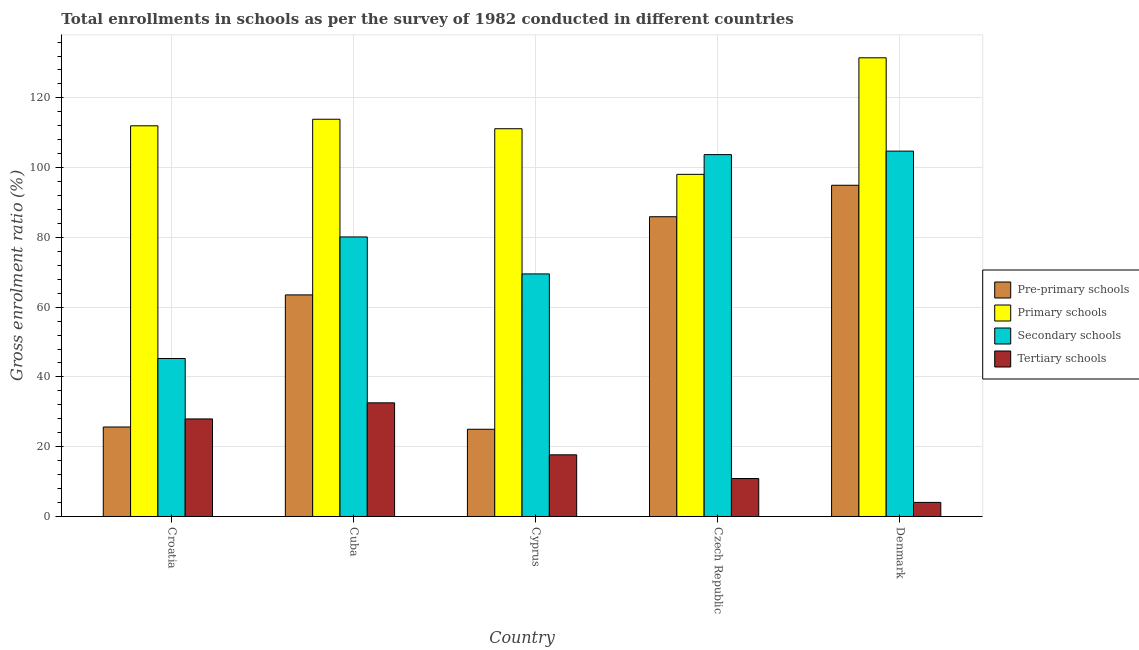How many different coloured bars are there?
Your answer should be compact. 4. How many groups of bars are there?
Provide a succinct answer. 5. Are the number of bars per tick equal to the number of legend labels?
Offer a terse response. Yes. Are the number of bars on each tick of the X-axis equal?
Your response must be concise. Yes. How many bars are there on the 5th tick from the left?
Your answer should be very brief. 4. What is the label of the 2nd group of bars from the left?
Provide a succinct answer. Cuba. In how many cases, is the number of bars for a given country not equal to the number of legend labels?
Offer a terse response. 0. What is the gross enrolment ratio in pre-primary schools in Denmark?
Your response must be concise. 94.95. Across all countries, what is the maximum gross enrolment ratio in pre-primary schools?
Offer a very short reply. 94.95. Across all countries, what is the minimum gross enrolment ratio in tertiary schools?
Offer a terse response. 4.04. In which country was the gross enrolment ratio in pre-primary schools minimum?
Your response must be concise. Cyprus. What is the total gross enrolment ratio in secondary schools in the graph?
Your answer should be compact. 403.42. What is the difference between the gross enrolment ratio in primary schools in Cuba and that in Denmark?
Offer a terse response. -17.61. What is the difference between the gross enrolment ratio in primary schools in Denmark and the gross enrolment ratio in secondary schools in Cuba?
Your answer should be compact. 51.35. What is the average gross enrolment ratio in primary schools per country?
Make the answer very short. 113.32. What is the difference between the gross enrolment ratio in secondary schools and gross enrolment ratio in tertiary schools in Cyprus?
Offer a very short reply. 51.86. In how many countries, is the gross enrolment ratio in secondary schools greater than 124 %?
Your response must be concise. 0. What is the ratio of the gross enrolment ratio in secondary schools in Croatia to that in Czech Republic?
Provide a short and direct response. 0.44. What is the difference between the highest and the second highest gross enrolment ratio in secondary schools?
Your answer should be very brief. 1. What is the difference between the highest and the lowest gross enrolment ratio in secondary schools?
Offer a very short reply. 59.45. Is the sum of the gross enrolment ratio in primary schools in Cuba and Cyprus greater than the maximum gross enrolment ratio in pre-primary schools across all countries?
Keep it short and to the point. Yes. What does the 4th bar from the left in Cuba represents?
Give a very brief answer. Tertiary schools. What does the 4th bar from the right in Cuba represents?
Offer a very short reply. Pre-primary schools. How many bars are there?
Offer a very short reply. 20. Are all the bars in the graph horizontal?
Ensure brevity in your answer.  No. What is the difference between two consecutive major ticks on the Y-axis?
Keep it short and to the point. 20. Are the values on the major ticks of Y-axis written in scientific E-notation?
Ensure brevity in your answer.  No. Does the graph contain grids?
Ensure brevity in your answer.  Yes. Where does the legend appear in the graph?
Ensure brevity in your answer.  Center right. How many legend labels are there?
Offer a terse response. 4. What is the title of the graph?
Give a very brief answer. Total enrollments in schools as per the survey of 1982 conducted in different countries. What is the Gross enrolment ratio (%) of Pre-primary schools in Croatia?
Your answer should be very brief. 25.65. What is the Gross enrolment ratio (%) in Primary schools in Croatia?
Your answer should be very brief. 111.99. What is the Gross enrolment ratio (%) of Secondary schools in Croatia?
Keep it short and to the point. 45.29. What is the Gross enrolment ratio (%) of Tertiary schools in Croatia?
Ensure brevity in your answer.  27.97. What is the Gross enrolment ratio (%) of Pre-primary schools in Cuba?
Provide a short and direct response. 63.52. What is the Gross enrolment ratio (%) in Primary schools in Cuba?
Your answer should be very brief. 113.87. What is the Gross enrolment ratio (%) in Secondary schools in Cuba?
Keep it short and to the point. 80.13. What is the Gross enrolment ratio (%) of Tertiary schools in Cuba?
Offer a very short reply. 32.58. What is the Gross enrolment ratio (%) of Pre-primary schools in Cyprus?
Offer a terse response. 25.01. What is the Gross enrolment ratio (%) in Primary schools in Cyprus?
Provide a succinct answer. 111.15. What is the Gross enrolment ratio (%) of Secondary schools in Cyprus?
Your answer should be very brief. 69.53. What is the Gross enrolment ratio (%) of Tertiary schools in Cyprus?
Make the answer very short. 17.68. What is the Gross enrolment ratio (%) in Pre-primary schools in Czech Republic?
Offer a terse response. 85.93. What is the Gross enrolment ratio (%) in Primary schools in Czech Republic?
Your answer should be very brief. 98.08. What is the Gross enrolment ratio (%) of Secondary schools in Czech Republic?
Provide a succinct answer. 103.73. What is the Gross enrolment ratio (%) of Tertiary schools in Czech Republic?
Offer a very short reply. 10.88. What is the Gross enrolment ratio (%) of Pre-primary schools in Denmark?
Your answer should be very brief. 94.95. What is the Gross enrolment ratio (%) of Primary schools in Denmark?
Your answer should be compact. 131.48. What is the Gross enrolment ratio (%) in Secondary schools in Denmark?
Ensure brevity in your answer.  104.73. What is the Gross enrolment ratio (%) in Tertiary schools in Denmark?
Provide a short and direct response. 4.04. Across all countries, what is the maximum Gross enrolment ratio (%) in Pre-primary schools?
Keep it short and to the point. 94.95. Across all countries, what is the maximum Gross enrolment ratio (%) in Primary schools?
Provide a succinct answer. 131.48. Across all countries, what is the maximum Gross enrolment ratio (%) of Secondary schools?
Make the answer very short. 104.73. Across all countries, what is the maximum Gross enrolment ratio (%) in Tertiary schools?
Give a very brief answer. 32.58. Across all countries, what is the minimum Gross enrolment ratio (%) in Pre-primary schools?
Your response must be concise. 25.01. Across all countries, what is the minimum Gross enrolment ratio (%) in Primary schools?
Keep it short and to the point. 98.08. Across all countries, what is the minimum Gross enrolment ratio (%) in Secondary schools?
Make the answer very short. 45.29. Across all countries, what is the minimum Gross enrolment ratio (%) in Tertiary schools?
Provide a succinct answer. 4.04. What is the total Gross enrolment ratio (%) of Pre-primary schools in the graph?
Your answer should be compact. 295.05. What is the total Gross enrolment ratio (%) in Primary schools in the graph?
Your answer should be compact. 566.58. What is the total Gross enrolment ratio (%) of Secondary schools in the graph?
Make the answer very short. 403.42. What is the total Gross enrolment ratio (%) in Tertiary schools in the graph?
Ensure brevity in your answer.  93.14. What is the difference between the Gross enrolment ratio (%) of Pre-primary schools in Croatia and that in Cuba?
Your answer should be very brief. -37.87. What is the difference between the Gross enrolment ratio (%) in Primary schools in Croatia and that in Cuba?
Ensure brevity in your answer.  -1.88. What is the difference between the Gross enrolment ratio (%) in Secondary schools in Croatia and that in Cuba?
Keep it short and to the point. -34.85. What is the difference between the Gross enrolment ratio (%) of Tertiary schools in Croatia and that in Cuba?
Provide a succinct answer. -4.61. What is the difference between the Gross enrolment ratio (%) in Pre-primary schools in Croatia and that in Cyprus?
Your answer should be very brief. 0.65. What is the difference between the Gross enrolment ratio (%) in Primary schools in Croatia and that in Cyprus?
Your answer should be compact. 0.84. What is the difference between the Gross enrolment ratio (%) of Secondary schools in Croatia and that in Cyprus?
Offer a terse response. -24.25. What is the difference between the Gross enrolment ratio (%) in Tertiary schools in Croatia and that in Cyprus?
Make the answer very short. 10.29. What is the difference between the Gross enrolment ratio (%) in Pre-primary schools in Croatia and that in Czech Republic?
Ensure brevity in your answer.  -60.27. What is the difference between the Gross enrolment ratio (%) in Primary schools in Croatia and that in Czech Republic?
Make the answer very short. 13.92. What is the difference between the Gross enrolment ratio (%) of Secondary schools in Croatia and that in Czech Republic?
Your answer should be very brief. -58.45. What is the difference between the Gross enrolment ratio (%) in Tertiary schools in Croatia and that in Czech Republic?
Keep it short and to the point. 17.08. What is the difference between the Gross enrolment ratio (%) in Pre-primary schools in Croatia and that in Denmark?
Ensure brevity in your answer.  -69.3. What is the difference between the Gross enrolment ratio (%) of Primary schools in Croatia and that in Denmark?
Your answer should be compact. -19.49. What is the difference between the Gross enrolment ratio (%) in Secondary schools in Croatia and that in Denmark?
Provide a short and direct response. -59.45. What is the difference between the Gross enrolment ratio (%) of Tertiary schools in Croatia and that in Denmark?
Ensure brevity in your answer.  23.93. What is the difference between the Gross enrolment ratio (%) of Pre-primary schools in Cuba and that in Cyprus?
Make the answer very short. 38.51. What is the difference between the Gross enrolment ratio (%) in Primary schools in Cuba and that in Cyprus?
Give a very brief answer. 2.72. What is the difference between the Gross enrolment ratio (%) of Secondary schools in Cuba and that in Cyprus?
Offer a terse response. 10.6. What is the difference between the Gross enrolment ratio (%) of Tertiary schools in Cuba and that in Cyprus?
Your response must be concise. 14.9. What is the difference between the Gross enrolment ratio (%) of Pre-primary schools in Cuba and that in Czech Republic?
Provide a short and direct response. -22.41. What is the difference between the Gross enrolment ratio (%) in Primary schools in Cuba and that in Czech Republic?
Make the answer very short. 15.8. What is the difference between the Gross enrolment ratio (%) of Secondary schools in Cuba and that in Czech Republic?
Provide a succinct answer. -23.6. What is the difference between the Gross enrolment ratio (%) of Tertiary schools in Cuba and that in Czech Republic?
Provide a succinct answer. 21.7. What is the difference between the Gross enrolment ratio (%) in Pre-primary schools in Cuba and that in Denmark?
Your answer should be very brief. -31.43. What is the difference between the Gross enrolment ratio (%) of Primary schools in Cuba and that in Denmark?
Provide a succinct answer. -17.61. What is the difference between the Gross enrolment ratio (%) of Secondary schools in Cuba and that in Denmark?
Your answer should be very brief. -24.6. What is the difference between the Gross enrolment ratio (%) of Tertiary schools in Cuba and that in Denmark?
Your response must be concise. 28.54. What is the difference between the Gross enrolment ratio (%) of Pre-primary schools in Cyprus and that in Czech Republic?
Your response must be concise. -60.92. What is the difference between the Gross enrolment ratio (%) of Primary schools in Cyprus and that in Czech Republic?
Offer a terse response. 13.08. What is the difference between the Gross enrolment ratio (%) in Secondary schools in Cyprus and that in Czech Republic?
Make the answer very short. -34.2. What is the difference between the Gross enrolment ratio (%) of Tertiary schools in Cyprus and that in Czech Republic?
Ensure brevity in your answer.  6.8. What is the difference between the Gross enrolment ratio (%) in Pre-primary schools in Cyprus and that in Denmark?
Your response must be concise. -69.94. What is the difference between the Gross enrolment ratio (%) of Primary schools in Cyprus and that in Denmark?
Your answer should be very brief. -20.33. What is the difference between the Gross enrolment ratio (%) of Secondary schools in Cyprus and that in Denmark?
Give a very brief answer. -35.2. What is the difference between the Gross enrolment ratio (%) of Tertiary schools in Cyprus and that in Denmark?
Offer a terse response. 13.64. What is the difference between the Gross enrolment ratio (%) in Pre-primary schools in Czech Republic and that in Denmark?
Provide a short and direct response. -9.02. What is the difference between the Gross enrolment ratio (%) of Primary schools in Czech Republic and that in Denmark?
Your answer should be very brief. -33.41. What is the difference between the Gross enrolment ratio (%) of Secondary schools in Czech Republic and that in Denmark?
Your answer should be very brief. -1. What is the difference between the Gross enrolment ratio (%) of Tertiary schools in Czech Republic and that in Denmark?
Ensure brevity in your answer.  6.84. What is the difference between the Gross enrolment ratio (%) in Pre-primary schools in Croatia and the Gross enrolment ratio (%) in Primary schools in Cuba?
Provide a short and direct response. -88.22. What is the difference between the Gross enrolment ratio (%) in Pre-primary schools in Croatia and the Gross enrolment ratio (%) in Secondary schools in Cuba?
Give a very brief answer. -54.48. What is the difference between the Gross enrolment ratio (%) of Pre-primary schools in Croatia and the Gross enrolment ratio (%) of Tertiary schools in Cuba?
Provide a short and direct response. -6.93. What is the difference between the Gross enrolment ratio (%) of Primary schools in Croatia and the Gross enrolment ratio (%) of Secondary schools in Cuba?
Your answer should be compact. 31.86. What is the difference between the Gross enrolment ratio (%) in Primary schools in Croatia and the Gross enrolment ratio (%) in Tertiary schools in Cuba?
Offer a terse response. 79.41. What is the difference between the Gross enrolment ratio (%) in Secondary schools in Croatia and the Gross enrolment ratio (%) in Tertiary schools in Cuba?
Provide a short and direct response. 12.71. What is the difference between the Gross enrolment ratio (%) of Pre-primary schools in Croatia and the Gross enrolment ratio (%) of Primary schools in Cyprus?
Give a very brief answer. -85.5. What is the difference between the Gross enrolment ratio (%) of Pre-primary schools in Croatia and the Gross enrolment ratio (%) of Secondary schools in Cyprus?
Give a very brief answer. -43.88. What is the difference between the Gross enrolment ratio (%) in Pre-primary schools in Croatia and the Gross enrolment ratio (%) in Tertiary schools in Cyprus?
Make the answer very short. 7.98. What is the difference between the Gross enrolment ratio (%) in Primary schools in Croatia and the Gross enrolment ratio (%) in Secondary schools in Cyprus?
Make the answer very short. 42.46. What is the difference between the Gross enrolment ratio (%) in Primary schools in Croatia and the Gross enrolment ratio (%) in Tertiary schools in Cyprus?
Offer a very short reply. 94.32. What is the difference between the Gross enrolment ratio (%) of Secondary schools in Croatia and the Gross enrolment ratio (%) of Tertiary schools in Cyprus?
Keep it short and to the point. 27.61. What is the difference between the Gross enrolment ratio (%) in Pre-primary schools in Croatia and the Gross enrolment ratio (%) in Primary schools in Czech Republic?
Provide a short and direct response. -72.42. What is the difference between the Gross enrolment ratio (%) of Pre-primary schools in Croatia and the Gross enrolment ratio (%) of Secondary schools in Czech Republic?
Offer a terse response. -78.08. What is the difference between the Gross enrolment ratio (%) of Pre-primary schools in Croatia and the Gross enrolment ratio (%) of Tertiary schools in Czech Republic?
Provide a succinct answer. 14.77. What is the difference between the Gross enrolment ratio (%) in Primary schools in Croatia and the Gross enrolment ratio (%) in Secondary schools in Czech Republic?
Your response must be concise. 8.26. What is the difference between the Gross enrolment ratio (%) in Primary schools in Croatia and the Gross enrolment ratio (%) in Tertiary schools in Czech Republic?
Offer a very short reply. 101.11. What is the difference between the Gross enrolment ratio (%) of Secondary schools in Croatia and the Gross enrolment ratio (%) of Tertiary schools in Czech Republic?
Provide a succinct answer. 34.4. What is the difference between the Gross enrolment ratio (%) of Pre-primary schools in Croatia and the Gross enrolment ratio (%) of Primary schools in Denmark?
Make the answer very short. -105.83. What is the difference between the Gross enrolment ratio (%) in Pre-primary schools in Croatia and the Gross enrolment ratio (%) in Secondary schools in Denmark?
Your response must be concise. -79.08. What is the difference between the Gross enrolment ratio (%) in Pre-primary schools in Croatia and the Gross enrolment ratio (%) in Tertiary schools in Denmark?
Ensure brevity in your answer.  21.61. What is the difference between the Gross enrolment ratio (%) of Primary schools in Croatia and the Gross enrolment ratio (%) of Secondary schools in Denmark?
Make the answer very short. 7.26. What is the difference between the Gross enrolment ratio (%) in Primary schools in Croatia and the Gross enrolment ratio (%) in Tertiary schools in Denmark?
Offer a very short reply. 107.95. What is the difference between the Gross enrolment ratio (%) of Secondary schools in Croatia and the Gross enrolment ratio (%) of Tertiary schools in Denmark?
Keep it short and to the point. 41.25. What is the difference between the Gross enrolment ratio (%) of Pre-primary schools in Cuba and the Gross enrolment ratio (%) of Primary schools in Cyprus?
Offer a terse response. -47.63. What is the difference between the Gross enrolment ratio (%) of Pre-primary schools in Cuba and the Gross enrolment ratio (%) of Secondary schools in Cyprus?
Provide a succinct answer. -6.02. What is the difference between the Gross enrolment ratio (%) in Pre-primary schools in Cuba and the Gross enrolment ratio (%) in Tertiary schools in Cyprus?
Your answer should be very brief. 45.84. What is the difference between the Gross enrolment ratio (%) in Primary schools in Cuba and the Gross enrolment ratio (%) in Secondary schools in Cyprus?
Make the answer very short. 44.34. What is the difference between the Gross enrolment ratio (%) in Primary schools in Cuba and the Gross enrolment ratio (%) in Tertiary schools in Cyprus?
Your answer should be compact. 96.2. What is the difference between the Gross enrolment ratio (%) in Secondary schools in Cuba and the Gross enrolment ratio (%) in Tertiary schools in Cyprus?
Provide a succinct answer. 62.46. What is the difference between the Gross enrolment ratio (%) of Pre-primary schools in Cuba and the Gross enrolment ratio (%) of Primary schools in Czech Republic?
Offer a terse response. -34.56. What is the difference between the Gross enrolment ratio (%) in Pre-primary schools in Cuba and the Gross enrolment ratio (%) in Secondary schools in Czech Republic?
Keep it short and to the point. -40.21. What is the difference between the Gross enrolment ratio (%) of Pre-primary schools in Cuba and the Gross enrolment ratio (%) of Tertiary schools in Czech Republic?
Offer a very short reply. 52.64. What is the difference between the Gross enrolment ratio (%) of Primary schools in Cuba and the Gross enrolment ratio (%) of Secondary schools in Czech Republic?
Provide a succinct answer. 10.14. What is the difference between the Gross enrolment ratio (%) in Primary schools in Cuba and the Gross enrolment ratio (%) in Tertiary schools in Czech Republic?
Provide a short and direct response. 102.99. What is the difference between the Gross enrolment ratio (%) of Secondary schools in Cuba and the Gross enrolment ratio (%) of Tertiary schools in Czech Republic?
Offer a terse response. 69.25. What is the difference between the Gross enrolment ratio (%) in Pre-primary schools in Cuba and the Gross enrolment ratio (%) in Primary schools in Denmark?
Your answer should be compact. -67.96. What is the difference between the Gross enrolment ratio (%) of Pre-primary schools in Cuba and the Gross enrolment ratio (%) of Secondary schools in Denmark?
Offer a terse response. -41.21. What is the difference between the Gross enrolment ratio (%) in Pre-primary schools in Cuba and the Gross enrolment ratio (%) in Tertiary schools in Denmark?
Offer a very short reply. 59.48. What is the difference between the Gross enrolment ratio (%) of Primary schools in Cuba and the Gross enrolment ratio (%) of Secondary schools in Denmark?
Your answer should be very brief. 9.14. What is the difference between the Gross enrolment ratio (%) in Primary schools in Cuba and the Gross enrolment ratio (%) in Tertiary schools in Denmark?
Ensure brevity in your answer.  109.83. What is the difference between the Gross enrolment ratio (%) of Secondary schools in Cuba and the Gross enrolment ratio (%) of Tertiary schools in Denmark?
Your answer should be very brief. 76.09. What is the difference between the Gross enrolment ratio (%) in Pre-primary schools in Cyprus and the Gross enrolment ratio (%) in Primary schools in Czech Republic?
Provide a succinct answer. -73.07. What is the difference between the Gross enrolment ratio (%) of Pre-primary schools in Cyprus and the Gross enrolment ratio (%) of Secondary schools in Czech Republic?
Make the answer very short. -78.73. What is the difference between the Gross enrolment ratio (%) of Pre-primary schools in Cyprus and the Gross enrolment ratio (%) of Tertiary schools in Czech Republic?
Provide a short and direct response. 14.12. What is the difference between the Gross enrolment ratio (%) of Primary schools in Cyprus and the Gross enrolment ratio (%) of Secondary schools in Czech Republic?
Your answer should be very brief. 7.42. What is the difference between the Gross enrolment ratio (%) of Primary schools in Cyprus and the Gross enrolment ratio (%) of Tertiary schools in Czech Republic?
Keep it short and to the point. 100.27. What is the difference between the Gross enrolment ratio (%) in Secondary schools in Cyprus and the Gross enrolment ratio (%) in Tertiary schools in Czech Republic?
Ensure brevity in your answer.  58.65. What is the difference between the Gross enrolment ratio (%) of Pre-primary schools in Cyprus and the Gross enrolment ratio (%) of Primary schools in Denmark?
Offer a very short reply. -106.48. What is the difference between the Gross enrolment ratio (%) of Pre-primary schools in Cyprus and the Gross enrolment ratio (%) of Secondary schools in Denmark?
Provide a short and direct response. -79.73. What is the difference between the Gross enrolment ratio (%) of Pre-primary schools in Cyprus and the Gross enrolment ratio (%) of Tertiary schools in Denmark?
Keep it short and to the point. 20.97. What is the difference between the Gross enrolment ratio (%) of Primary schools in Cyprus and the Gross enrolment ratio (%) of Secondary schools in Denmark?
Give a very brief answer. 6.42. What is the difference between the Gross enrolment ratio (%) of Primary schools in Cyprus and the Gross enrolment ratio (%) of Tertiary schools in Denmark?
Your response must be concise. 107.11. What is the difference between the Gross enrolment ratio (%) in Secondary schools in Cyprus and the Gross enrolment ratio (%) in Tertiary schools in Denmark?
Provide a succinct answer. 65.5. What is the difference between the Gross enrolment ratio (%) in Pre-primary schools in Czech Republic and the Gross enrolment ratio (%) in Primary schools in Denmark?
Provide a succinct answer. -45.56. What is the difference between the Gross enrolment ratio (%) of Pre-primary schools in Czech Republic and the Gross enrolment ratio (%) of Secondary schools in Denmark?
Offer a terse response. -18.81. What is the difference between the Gross enrolment ratio (%) of Pre-primary schools in Czech Republic and the Gross enrolment ratio (%) of Tertiary schools in Denmark?
Provide a short and direct response. 81.89. What is the difference between the Gross enrolment ratio (%) of Primary schools in Czech Republic and the Gross enrolment ratio (%) of Secondary schools in Denmark?
Keep it short and to the point. -6.66. What is the difference between the Gross enrolment ratio (%) of Primary schools in Czech Republic and the Gross enrolment ratio (%) of Tertiary schools in Denmark?
Offer a terse response. 94.04. What is the difference between the Gross enrolment ratio (%) of Secondary schools in Czech Republic and the Gross enrolment ratio (%) of Tertiary schools in Denmark?
Offer a terse response. 99.69. What is the average Gross enrolment ratio (%) in Pre-primary schools per country?
Offer a terse response. 59.01. What is the average Gross enrolment ratio (%) of Primary schools per country?
Keep it short and to the point. 113.32. What is the average Gross enrolment ratio (%) of Secondary schools per country?
Your answer should be very brief. 80.68. What is the average Gross enrolment ratio (%) of Tertiary schools per country?
Ensure brevity in your answer.  18.63. What is the difference between the Gross enrolment ratio (%) in Pre-primary schools and Gross enrolment ratio (%) in Primary schools in Croatia?
Offer a terse response. -86.34. What is the difference between the Gross enrolment ratio (%) of Pre-primary schools and Gross enrolment ratio (%) of Secondary schools in Croatia?
Offer a very short reply. -19.63. What is the difference between the Gross enrolment ratio (%) of Pre-primary schools and Gross enrolment ratio (%) of Tertiary schools in Croatia?
Your response must be concise. -2.31. What is the difference between the Gross enrolment ratio (%) of Primary schools and Gross enrolment ratio (%) of Secondary schools in Croatia?
Provide a succinct answer. 66.71. What is the difference between the Gross enrolment ratio (%) of Primary schools and Gross enrolment ratio (%) of Tertiary schools in Croatia?
Provide a succinct answer. 84.03. What is the difference between the Gross enrolment ratio (%) of Secondary schools and Gross enrolment ratio (%) of Tertiary schools in Croatia?
Provide a succinct answer. 17.32. What is the difference between the Gross enrolment ratio (%) of Pre-primary schools and Gross enrolment ratio (%) of Primary schools in Cuba?
Your answer should be compact. -50.35. What is the difference between the Gross enrolment ratio (%) in Pre-primary schools and Gross enrolment ratio (%) in Secondary schools in Cuba?
Provide a short and direct response. -16.61. What is the difference between the Gross enrolment ratio (%) in Pre-primary schools and Gross enrolment ratio (%) in Tertiary schools in Cuba?
Ensure brevity in your answer.  30.94. What is the difference between the Gross enrolment ratio (%) in Primary schools and Gross enrolment ratio (%) in Secondary schools in Cuba?
Your answer should be compact. 33.74. What is the difference between the Gross enrolment ratio (%) in Primary schools and Gross enrolment ratio (%) in Tertiary schools in Cuba?
Your answer should be very brief. 81.29. What is the difference between the Gross enrolment ratio (%) of Secondary schools and Gross enrolment ratio (%) of Tertiary schools in Cuba?
Provide a succinct answer. 47.55. What is the difference between the Gross enrolment ratio (%) in Pre-primary schools and Gross enrolment ratio (%) in Primary schools in Cyprus?
Your response must be concise. -86.15. What is the difference between the Gross enrolment ratio (%) in Pre-primary schools and Gross enrolment ratio (%) in Secondary schools in Cyprus?
Make the answer very short. -44.53. What is the difference between the Gross enrolment ratio (%) of Pre-primary schools and Gross enrolment ratio (%) of Tertiary schools in Cyprus?
Offer a terse response. 7.33. What is the difference between the Gross enrolment ratio (%) of Primary schools and Gross enrolment ratio (%) of Secondary schools in Cyprus?
Your answer should be compact. 41.62. What is the difference between the Gross enrolment ratio (%) of Primary schools and Gross enrolment ratio (%) of Tertiary schools in Cyprus?
Provide a short and direct response. 93.48. What is the difference between the Gross enrolment ratio (%) of Secondary schools and Gross enrolment ratio (%) of Tertiary schools in Cyprus?
Provide a succinct answer. 51.86. What is the difference between the Gross enrolment ratio (%) of Pre-primary schools and Gross enrolment ratio (%) of Primary schools in Czech Republic?
Give a very brief answer. -12.15. What is the difference between the Gross enrolment ratio (%) in Pre-primary schools and Gross enrolment ratio (%) in Secondary schools in Czech Republic?
Provide a short and direct response. -17.81. What is the difference between the Gross enrolment ratio (%) of Pre-primary schools and Gross enrolment ratio (%) of Tertiary schools in Czech Republic?
Ensure brevity in your answer.  75.05. What is the difference between the Gross enrolment ratio (%) in Primary schools and Gross enrolment ratio (%) in Secondary schools in Czech Republic?
Provide a succinct answer. -5.66. What is the difference between the Gross enrolment ratio (%) of Primary schools and Gross enrolment ratio (%) of Tertiary schools in Czech Republic?
Your response must be concise. 87.2. What is the difference between the Gross enrolment ratio (%) in Secondary schools and Gross enrolment ratio (%) in Tertiary schools in Czech Republic?
Your answer should be compact. 92.85. What is the difference between the Gross enrolment ratio (%) of Pre-primary schools and Gross enrolment ratio (%) of Primary schools in Denmark?
Your answer should be compact. -36.53. What is the difference between the Gross enrolment ratio (%) of Pre-primary schools and Gross enrolment ratio (%) of Secondary schools in Denmark?
Offer a terse response. -9.78. What is the difference between the Gross enrolment ratio (%) in Pre-primary schools and Gross enrolment ratio (%) in Tertiary schools in Denmark?
Your response must be concise. 90.91. What is the difference between the Gross enrolment ratio (%) of Primary schools and Gross enrolment ratio (%) of Secondary schools in Denmark?
Offer a very short reply. 26.75. What is the difference between the Gross enrolment ratio (%) of Primary schools and Gross enrolment ratio (%) of Tertiary schools in Denmark?
Make the answer very short. 127.44. What is the difference between the Gross enrolment ratio (%) in Secondary schools and Gross enrolment ratio (%) in Tertiary schools in Denmark?
Make the answer very short. 100.69. What is the ratio of the Gross enrolment ratio (%) in Pre-primary schools in Croatia to that in Cuba?
Make the answer very short. 0.4. What is the ratio of the Gross enrolment ratio (%) in Primary schools in Croatia to that in Cuba?
Give a very brief answer. 0.98. What is the ratio of the Gross enrolment ratio (%) in Secondary schools in Croatia to that in Cuba?
Provide a short and direct response. 0.57. What is the ratio of the Gross enrolment ratio (%) in Tertiary schools in Croatia to that in Cuba?
Give a very brief answer. 0.86. What is the ratio of the Gross enrolment ratio (%) in Pre-primary schools in Croatia to that in Cyprus?
Offer a terse response. 1.03. What is the ratio of the Gross enrolment ratio (%) of Primary schools in Croatia to that in Cyprus?
Offer a very short reply. 1.01. What is the ratio of the Gross enrolment ratio (%) of Secondary schools in Croatia to that in Cyprus?
Offer a very short reply. 0.65. What is the ratio of the Gross enrolment ratio (%) in Tertiary schools in Croatia to that in Cyprus?
Ensure brevity in your answer.  1.58. What is the ratio of the Gross enrolment ratio (%) of Pre-primary schools in Croatia to that in Czech Republic?
Make the answer very short. 0.3. What is the ratio of the Gross enrolment ratio (%) of Primary schools in Croatia to that in Czech Republic?
Your answer should be very brief. 1.14. What is the ratio of the Gross enrolment ratio (%) in Secondary schools in Croatia to that in Czech Republic?
Keep it short and to the point. 0.44. What is the ratio of the Gross enrolment ratio (%) in Tertiary schools in Croatia to that in Czech Republic?
Give a very brief answer. 2.57. What is the ratio of the Gross enrolment ratio (%) of Pre-primary schools in Croatia to that in Denmark?
Ensure brevity in your answer.  0.27. What is the ratio of the Gross enrolment ratio (%) of Primary schools in Croatia to that in Denmark?
Ensure brevity in your answer.  0.85. What is the ratio of the Gross enrolment ratio (%) of Secondary schools in Croatia to that in Denmark?
Keep it short and to the point. 0.43. What is the ratio of the Gross enrolment ratio (%) of Tertiary schools in Croatia to that in Denmark?
Ensure brevity in your answer.  6.92. What is the ratio of the Gross enrolment ratio (%) in Pre-primary schools in Cuba to that in Cyprus?
Keep it short and to the point. 2.54. What is the ratio of the Gross enrolment ratio (%) in Primary schools in Cuba to that in Cyprus?
Keep it short and to the point. 1.02. What is the ratio of the Gross enrolment ratio (%) in Secondary schools in Cuba to that in Cyprus?
Your answer should be very brief. 1.15. What is the ratio of the Gross enrolment ratio (%) of Tertiary schools in Cuba to that in Cyprus?
Give a very brief answer. 1.84. What is the ratio of the Gross enrolment ratio (%) of Pre-primary schools in Cuba to that in Czech Republic?
Keep it short and to the point. 0.74. What is the ratio of the Gross enrolment ratio (%) in Primary schools in Cuba to that in Czech Republic?
Ensure brevity in your answer.  1.16. What is the ratio of the Gross enrolment ratio (%) of Secondary schools in Cuba to that in Czech Republic?
Your response must be concise. 0.77. What is the ratio of the Gross enrolment ratio (%) in Tertiary schools in Cuba to that in Czech Republic?
Ensure brevity in your answer.  2.99. What is the ratio of the Gross enrolment ratio (%) in Pre-primary schools in Cuba to that in Denmark?
Keep it short and to the point. 0.67. What is the ratio of the Gross enrolment ratio (%) in Primary schools in Cuba to that in Denmark?
Provide a succinct answer. 0.87. What is the ratio of the Gross enrolment ratio (%) of Secondary schools in Cuba to that in Denmark?
Keep it short and to the point. 0.77. What is the ratio of the Gross enrolment ratio (%) in Tertiary schools in Cuba to that in Denmark?
Your answer should be compact. 8.06. What is the ratio of the Gross enrolment ratio (%) in Pre-primary schools in Cyprus to that in Czech Republic?
Provide a succinct answer. 0.29. What is the ratio of the Gross enrolment ratio (%) of Primary schools in Cyprus to that in Czech Republic?
Provide a short and direct response. 1.13. What is the ratio of the Gross enrolment ratio (%) in Secondary schools in Cyprus to that in Czech Republic?
Make the answer very short. 0.67. What is the ratio of the Gross enrolment ratio (%) of Tertiary schools in Cyprus to that in Czech Republic?
Provide a short and direct response. 1.62. What is the ratio of the Gross enrolment ratio (%) in Pre-primary schools in Cyprus to that in Denmark?
Provide a succinct answer. 0.26. What is the ratio of the Gross enrolment ratio (%) of Primary schools in Cyprus to that in Denmark?
Your response must be concise. 0.85. What is the ratio of the Gross enrolment ratio (%) in Secondary schools in Cyprus to that in Denmark?
Your response must be concise. 0.66. What is the ratio of the Gross enrolment ratio (%) in Tertiary schools in Cyprus to that in Denmark?
Your response must be concise. 4.38. What is the ratio of the Gross enrolment ratio (%) in Pre-primary schools in Czech Republic to that in Denmark?
Keep it short and to the point. 0.91. What is the ratio of the Gross enrolment ratio (%) in Primary schools in Czech Republic to that in Denmark?
Make the answer very short. 0.75. What is the ratio of the Gross enrolment ratio (%) in Secondary schools in Czech Republic to that in Denmark?
Give a very brief answer. 0.99. What is the ratio of the Gross enrolment ratio (%) of Tertiary schools in Czech Republic to that in Denmark?
Offer a terse response. 2.69. What is the difference between the highest and the second highest Gross enrolment ratio (%) in Pre-primary schools?
Make the answer very short. 9.02. What is the difference between the highest and the second highest Gross enrolment ratio (%) in Primary schools?
Offer a very short reply. 17.61. What is the difference between the highest and the second highest Gross enrolment ratio (%) of Tertiary schools?
Your answer should be very brief. 4.61. What is the difference between the highest and the lowest Gross enrolment ratio (%) of Pre-primary schools?
Your answer should be very brief. 69.94. What is the difference between the highest and the lowest Gross enrolment ratio (%) of Primary schools?
Ensure brevity in your answer.  33.41. What is the difference between the highest and the lowest Gross enrolment ratio (%) of Secondary schools?
Your answer should be very brief. 59.45. What is the difference between the highest and the lowest Gross enrolment ratio (%) in Tertiary schools?
Your response must be concise. 28.54. 